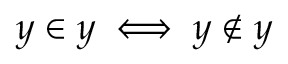Convert formula to latex. <formula><loc_0><loc_0><loc_500><loc_500>y \in y \iff y \notin y</formula> 